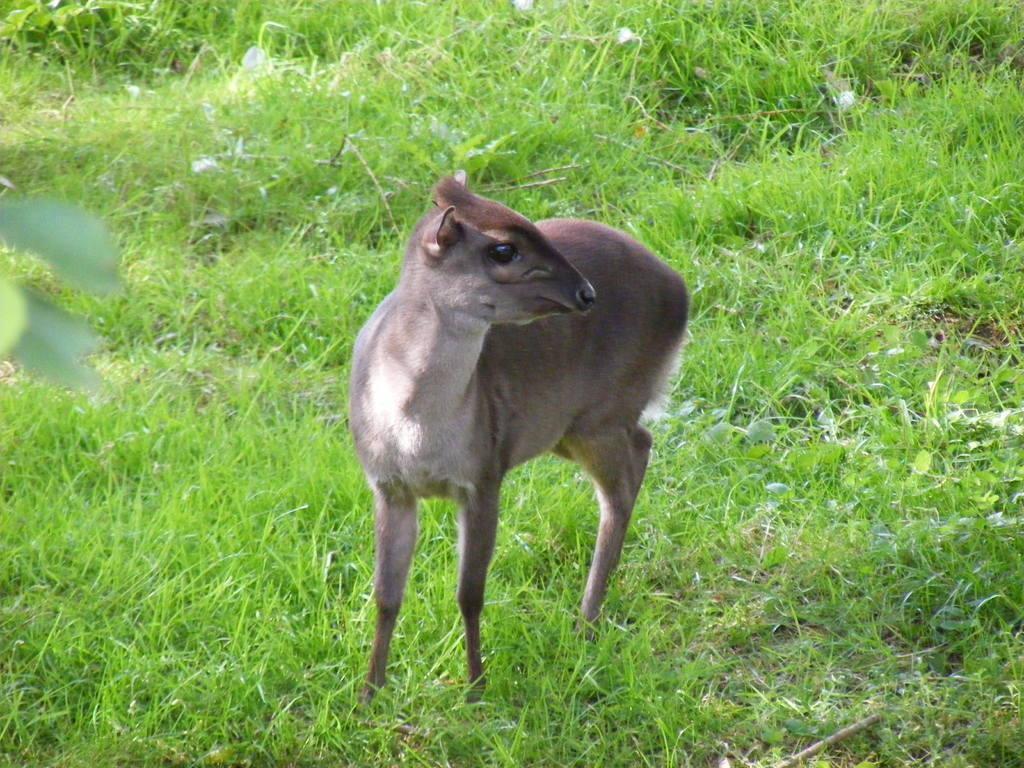In one or two sentences, can you explain what this image depicts? In this image in the center there is an animal, at the bottom there is grass and there are some leaves on the left side. 